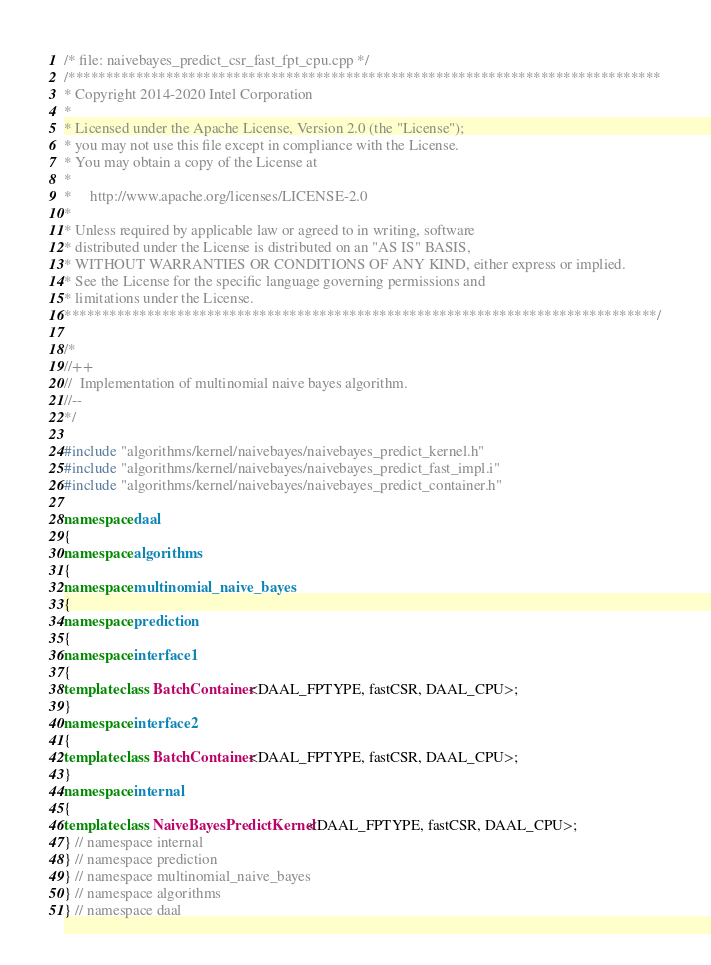<code> <loc_0><loc_0><loc_500><loc_500><_C++_>/* file: naivebayes_predict_csr_fast_fpt_cpu.cpp */
/*******************************************************************************
* Copyright 2014-2020 Intel Corporation
*
* Licensed under the Apache License, Version 2.0 (the "License");
* you may not use this file except in compliance with the License.
* You may obtain a copy of the License at
*
*     http://www.apache.org/licenses/LICENSE-2.0
*
* Unless required by applicable law or agreed to in writing, software
* distributed under the License is distributed on an "AS IS" BASIS,
* WITHOUT WARRANTIES OR CONDITIONS OF ANY KIND, either express or implied.
* See the License for the specific language governing permissions and
* limitations under the License.
*******************************************************************************/

/*
//++
//  Implementation of multinomial naive bayes algorithm.
//--
*/

#include "algorithms/kernel/naivebayes/naivebayes_predict_kernel.h"
#include "algorithms/kernel/naivebayes/naivebayes_predict_fast_impl.i"
#include "algorithms/kernel/naivebayes/naivebayes_predict_container.h"

namespace daal
{
namespace algorithms
{
namespace multinomial_naive_bayes
{
namespace prediction
{
namespace interface1
{
template class BatchContainer<DAAL_FPTYPE, fastCSR, DAAL_CPU>;
}
namespace interface2
{
template class BatchContainer<DAAL_FPTYPE, fastCSR, DAAL_CPU>;
}
namespace internal
{
template class NaiveBayesPredictKernel<DAAL_FPTYPE, fastCSR, DAAL_CPU>;
} // namespace internal
} // namespace prediction
} // namespace multinomial_naive_bayes
} // namespace algorithms
} // namespace daal
</code> 